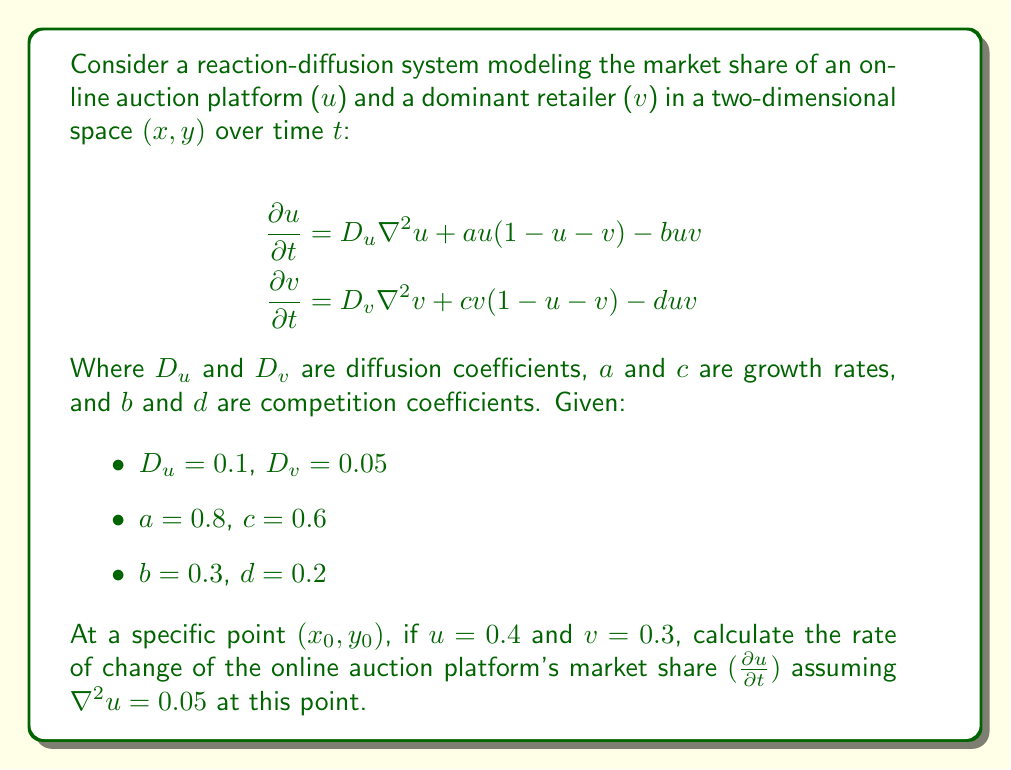Show me your answer to this math problem. To solve this problem, we'll follow these steps:

1) We're given the partial differential equation for $u$:

   $$\frac{\partial u}{\partial t} = D_u \nabla^2 u + au(1-u-v) - buv$$

2) We need to substitute the given values:
   - $D_u = 0.1$
   - $a = 0.8$
   - $b = 0.3$
   - $u = 0.4$
   - $v = 0.3$
   - $\nabla^2 u = 0.05$

3) Let's substitute these into the equation:

   $$\frac{\partial u}{\partial t} = 0.1(0.05) + 0.8(0.4)(1-0.4-0.3) - 0.3(0.4)(0.3)$$

4) Let's solve each term:
   - $0.1(0.05) = 0.005$
   - $0.8(0.4)(1-0.4-0.3) = 0.8(0.4)(0.3) = 0.096$
   - $0.3(0.4)(0.3) = 0.036$

5) Now we can calculate $\frac{\partial u}{\partial t}$:

   $$\frac{\partial u}{\partial t} = 0.005 + 0.096 - 0.036 = 0.065$$

Therefore, the rate of change of the online auction platform's market share at the given point is 0.065.
Answer: $\frac{\partial u}{\partial t} = 0.065$ 